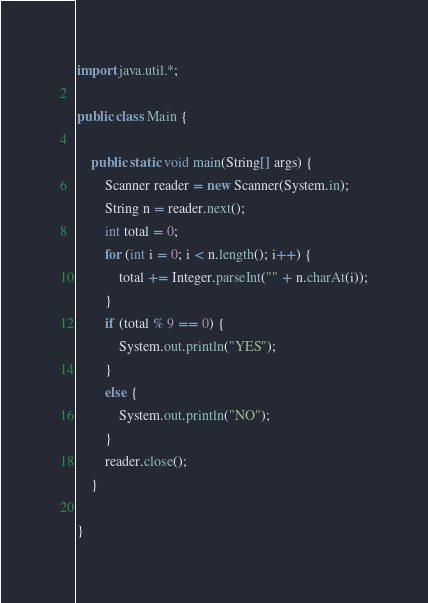<code> <loc_0><loc_0><loc_500><loc_500><_Java_>import java.util.*;

public class Main {

	public static void main(String[] args) {
		Scanner reader = new Scanner(System.in);
		String n = reader.next();
		int total = 0;
		for (int i = 0; i < n.length(); i++) {
			total += Integer.parseInt("" + n.charAt(i));
		}
		if (total % 9 == 0) {
			System.out.println("YES");
		}
		else {
			System.out.println("NO");
		}
		reader.close();
	}
	
}
</code> 